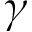<formula> <loc_0><loc_0><loc_500><loc_500>\gamma</formula> 